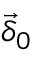<formula> <loc_0><loc_0><loc_500><loc_500>\vec { \delta } _ { 0 }</formula> 